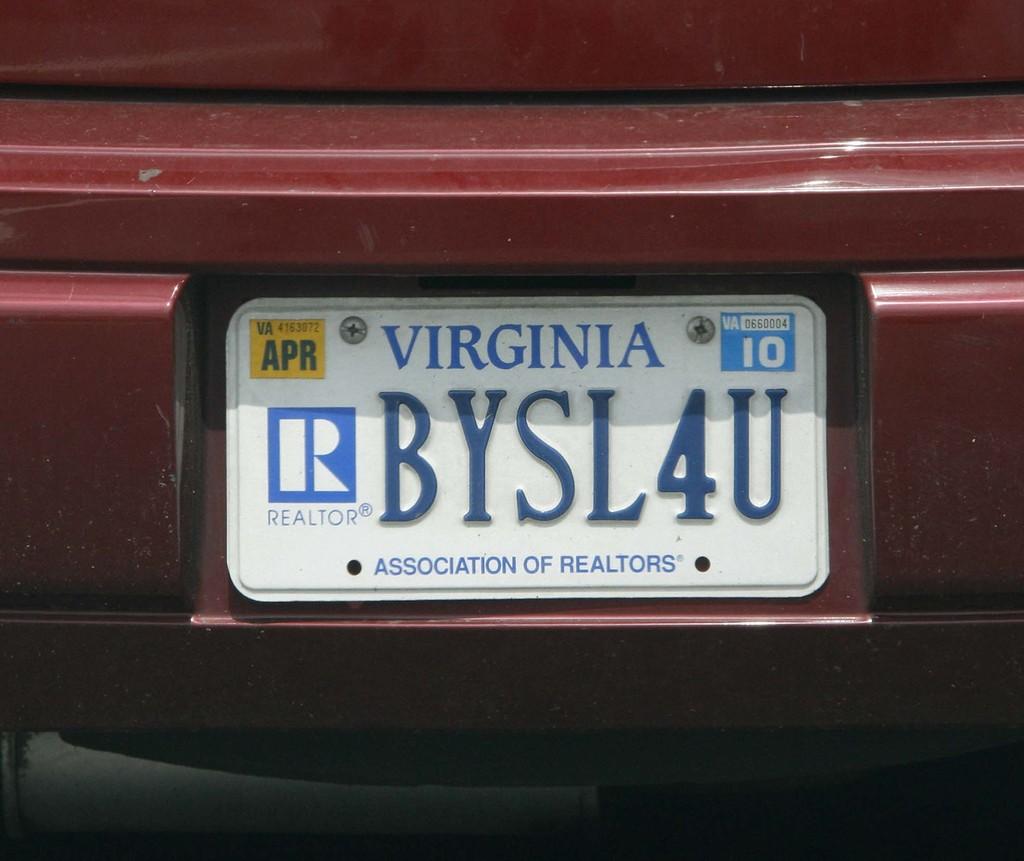What is the license plate number?
Keep it short and to the point. Bysl4u. 